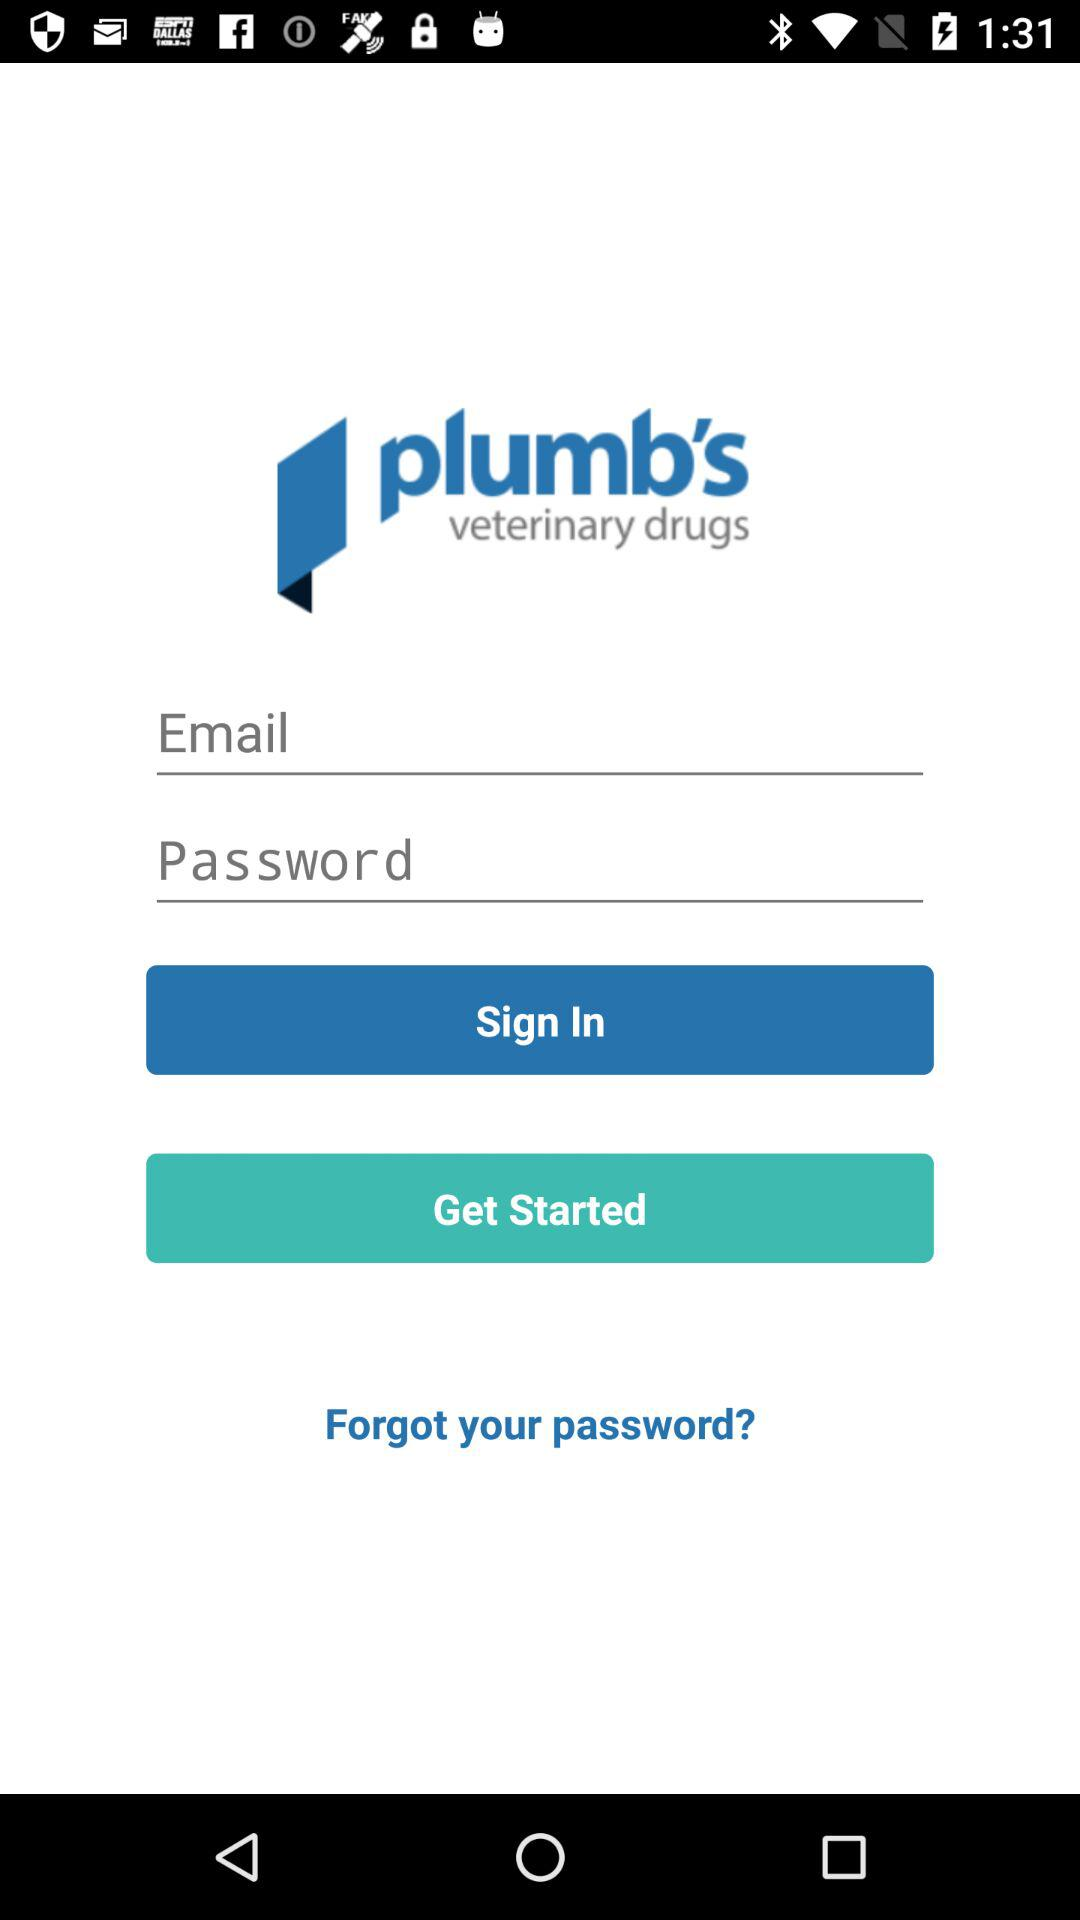What is the application name? The application name is "plumb's veterinary drugs". 